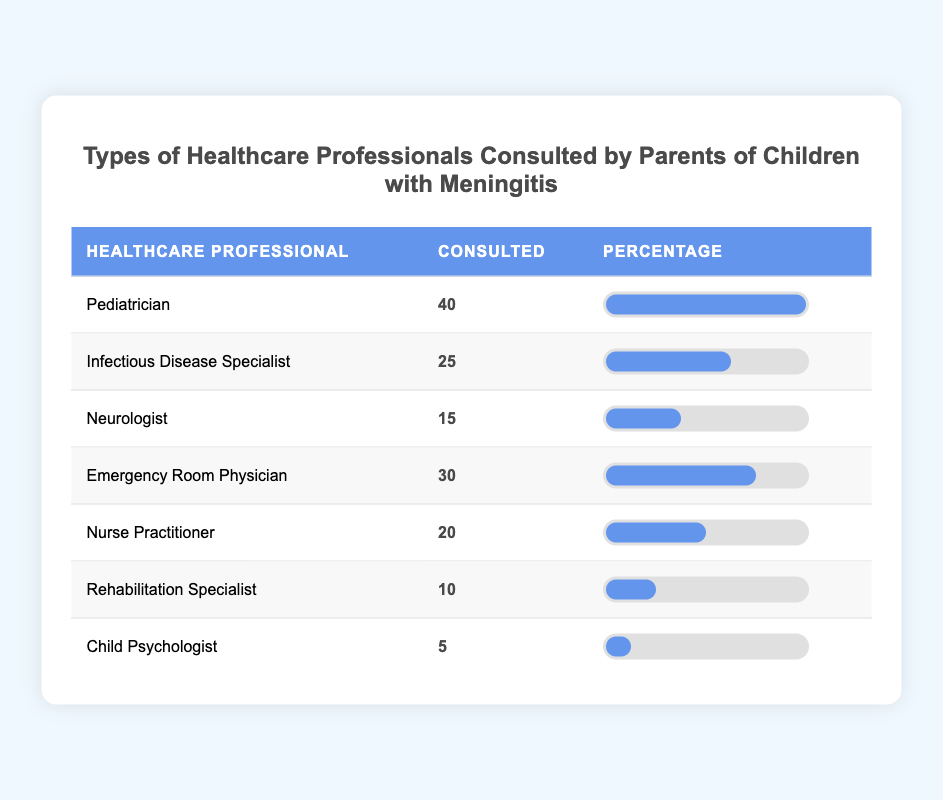What type of healthcare professional was consulted the most by parents? By looking at the "Consulted" column in the table, we see that the Pediatrician has the highest number, with 40 consultations, compared to other professionals.
Answer: Pediatrician How many parents consulted an Infectious Disease Specialist? The table clearly shows that 25 parents consulted an Infectious Disease Specialist.
Answer: 25 What is the total number of consultations from all healthcare professionals listed? To find the total consultations, we add the numbers from the "Consulted" column: 40 + 25 + 15 + 30 + 20 + 10 + 5 = 145.
Answer: 145 Which healthcare professional had the least consultations and how many? The "Consulted" column indicates that the Child Psychologist had the least consultations, with only 5 parents consulting them.
Answer: Child Psychologist, 5 Is it true that more parents consulted a Neurologist than a Rehabilitation Specialist? By comparing the consulted numbers, 15 parents consulted a Neurologist, while 10 consulted a Rehabilitation Specialist. Therefore, it is true.
Answer: Yes How much more frequent were consultations with Emergency Room Physicians compared to Rehabilitation Specialists? We see that the consultations for Emergency Room Physicians are at 30 and for Rehabilitation Specialists at 10. The difference is 30 - 10 = 20, indicating that there were 20 more consultations with Emergency Room Physicians.
Answer: 20 What percentage of parents consulted a Nurse Practitioner compared to the total consultations? To calculate the percentage, we take the number who consulted a Nurse Practitioner (20) and divide it by the total consultations (145), then multiply by 100: (20 / 145) * 100 ≈ 13.79%.
Answer: Approximately 13.79% Which two healthcare professionals combined had more consultations than Pediatricians? The consultations for Pediatricians are 40. Looking at Infectious Disease Specialists (25) and Emergency Room Physicians (30), their combined consultations are 25 + 30 = 55, which is more than 40.
Answer: Infectious Disease Specialist and Emergency Room Physician How many more parents consulted a Nurse Practitioner than a Child Psychologist? The table shows that 20 parents consulted a Nurse Practitioner and 5 consulted a Child Psychologist. The difference is 20 - 5 = 15.
Answer: 15 